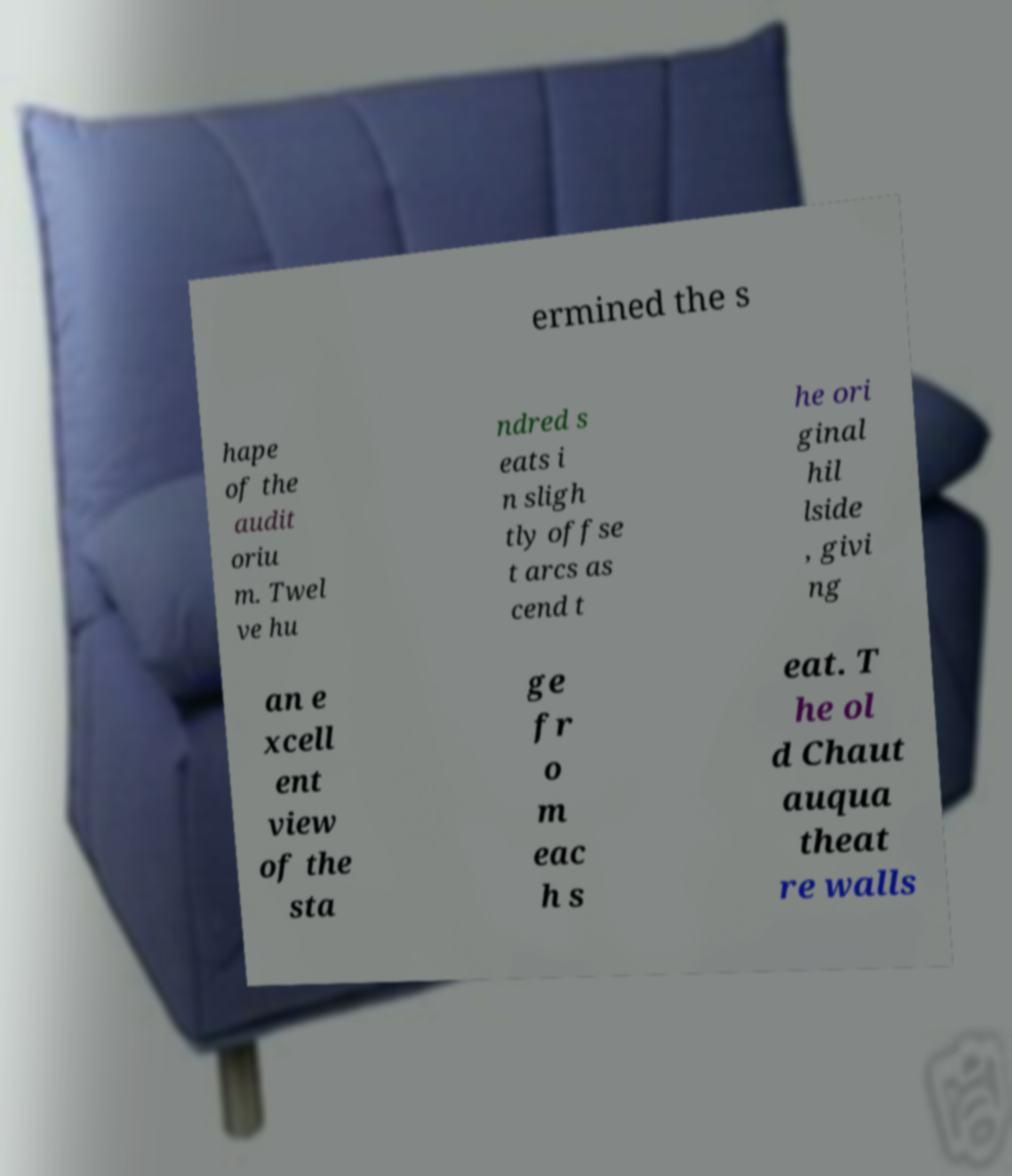Could you assist in decoding the text presented in this image and type it out clearly? ermined the s hape of the audit oriu m. Twel ve hu ndred s eats i n sligh tly offse t arcs as cend t he ori ginal hil lside , givi ng an e xcell ent view of the sta ge fr o m eac h s eat. T he ol d Chaut auqua theat re walls 